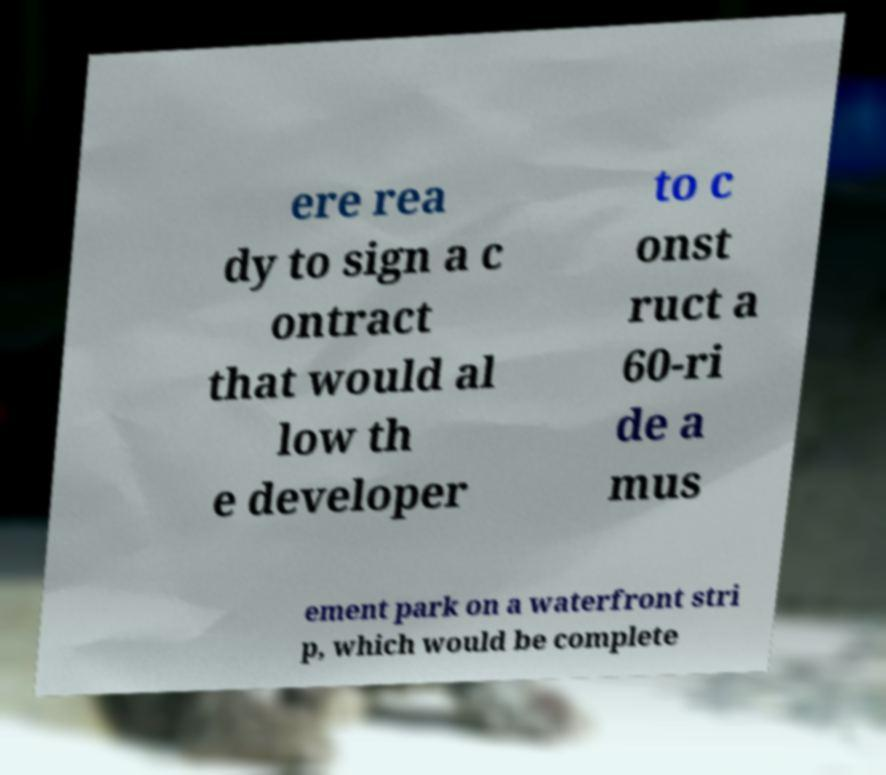Can you accurately transcribe the text from the provided image for me? ere rea dy to sign a c ontract that would al low th e developer to c onst ruct a 60-ri de a mus ement park on a waterfront stri p, which would be complete 